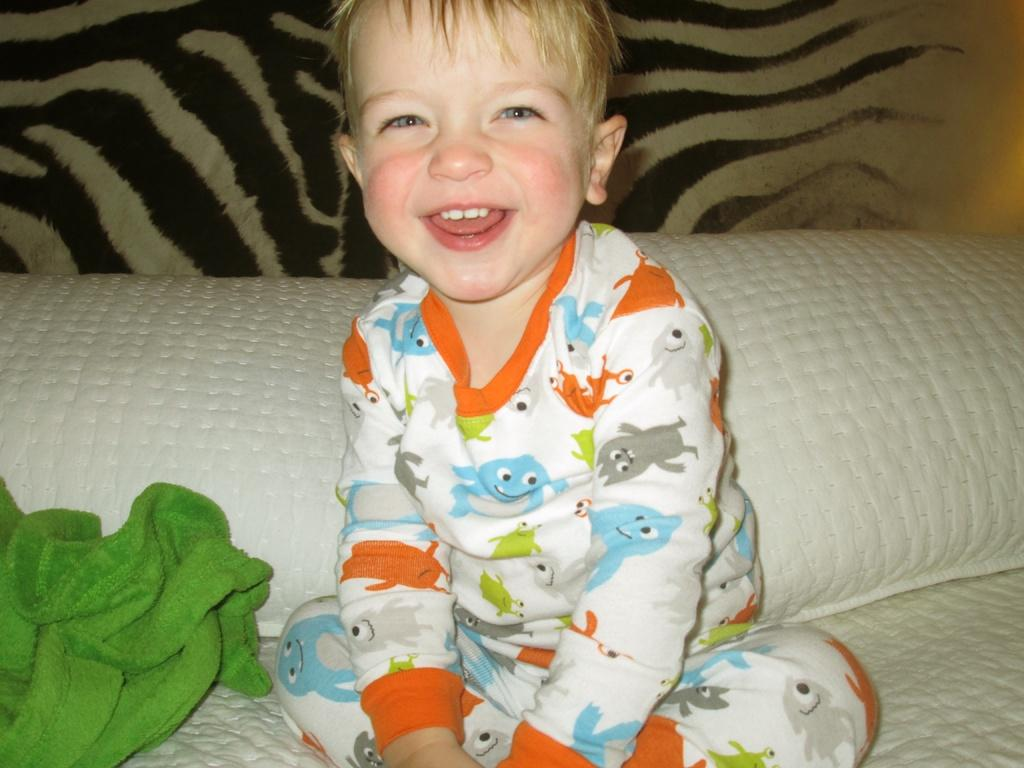Who is the main subject in the image? There is a boy in the image. What is the boy doing in the image? The boy is sitting on a bed. What can be seen on the bed besides the boy? There are two pillows and a towel on the bed. What flavor of ice cream is the boy holding in the image? There is no ice cream present in the image, so it is not possible to determine the flavor. 